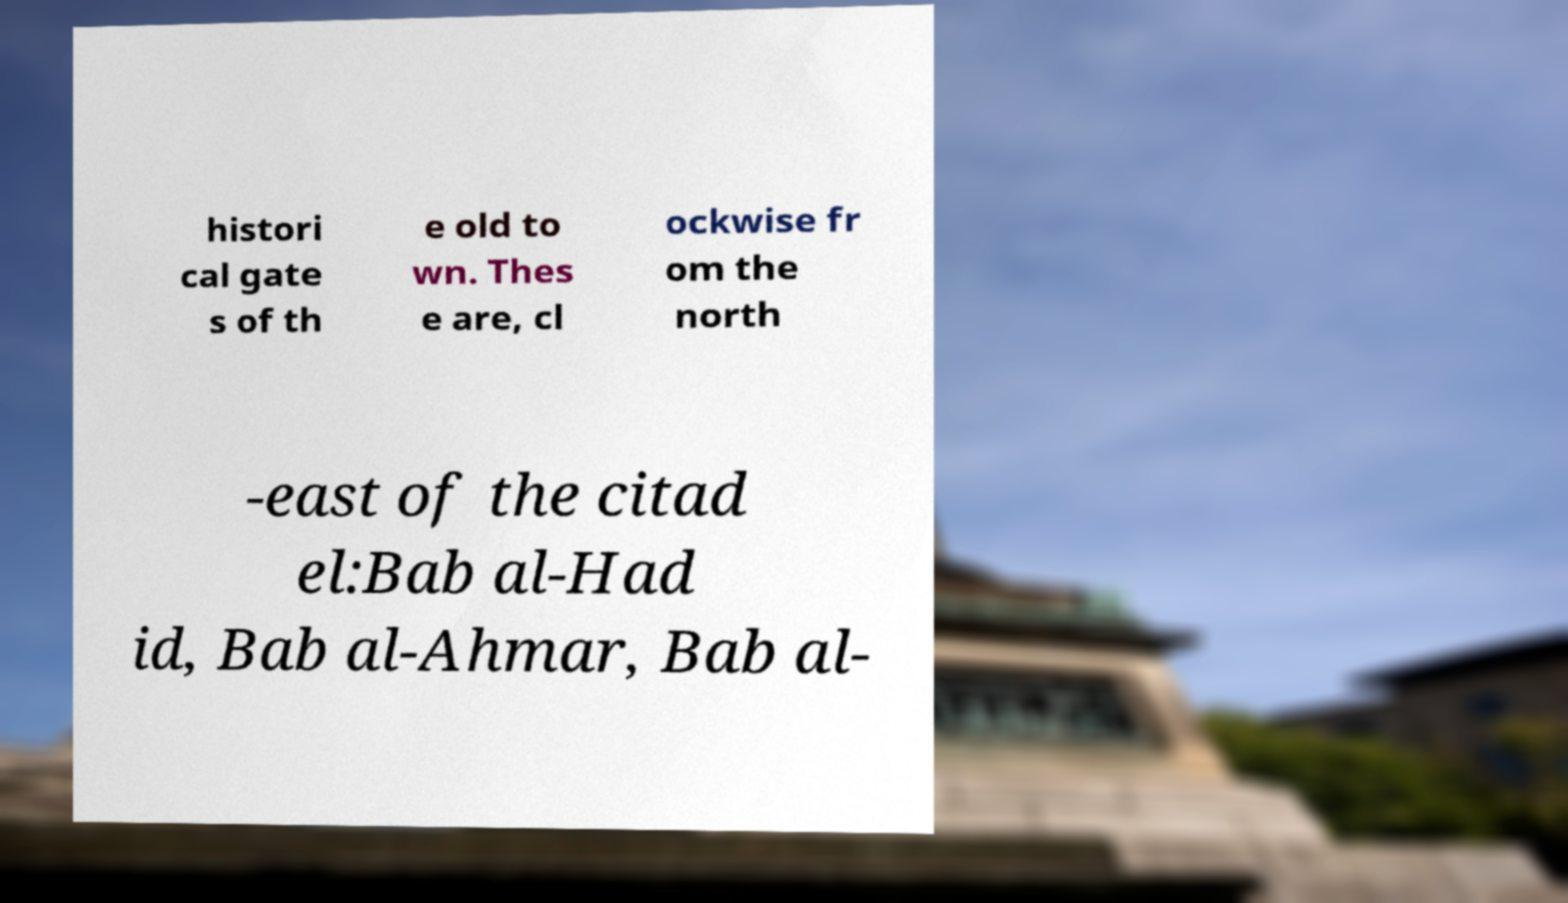I need the written content from this picture converted into text. Can you do that? histori cal gate s of th e old to wn. Thes e are, cl ockwise fr om the north -east of the citad el:Bab al-Had id, Bab al-Ahmar, Bab al- 